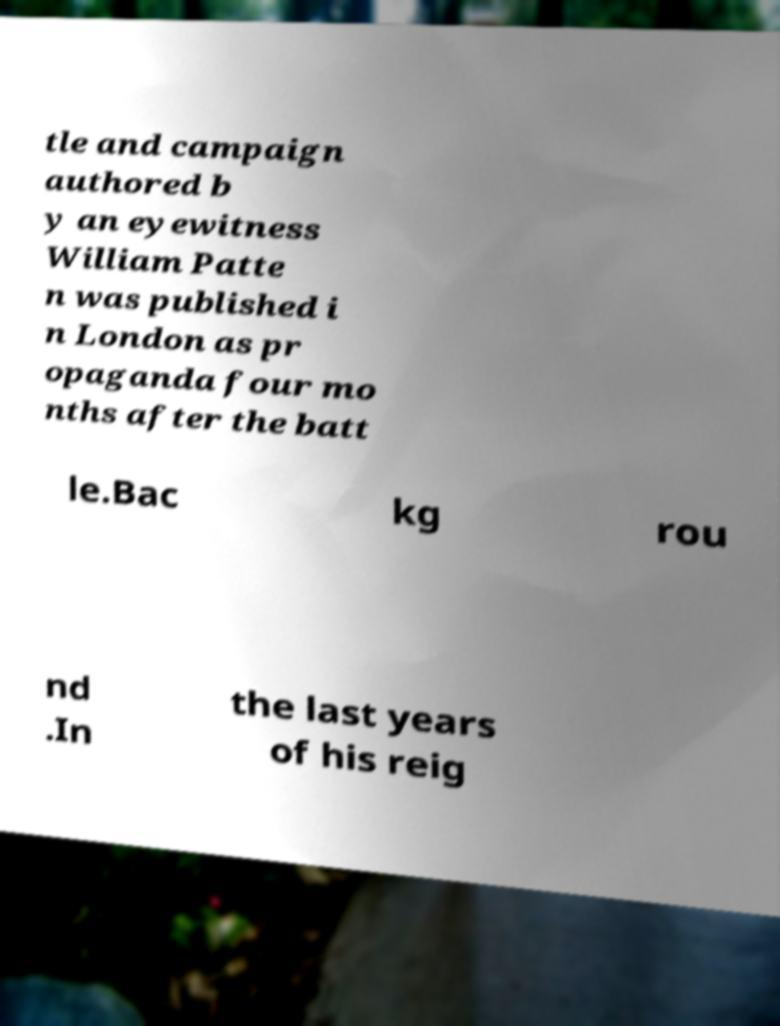For documentation purposes, I need the text within this image transcribed. Could you provide that? tle and campaign authored b y an eyewitness William Patte n was published i n London as pr opaganda four mo nths after the batt le.Bac kg rou nd .In the last years of his reig 